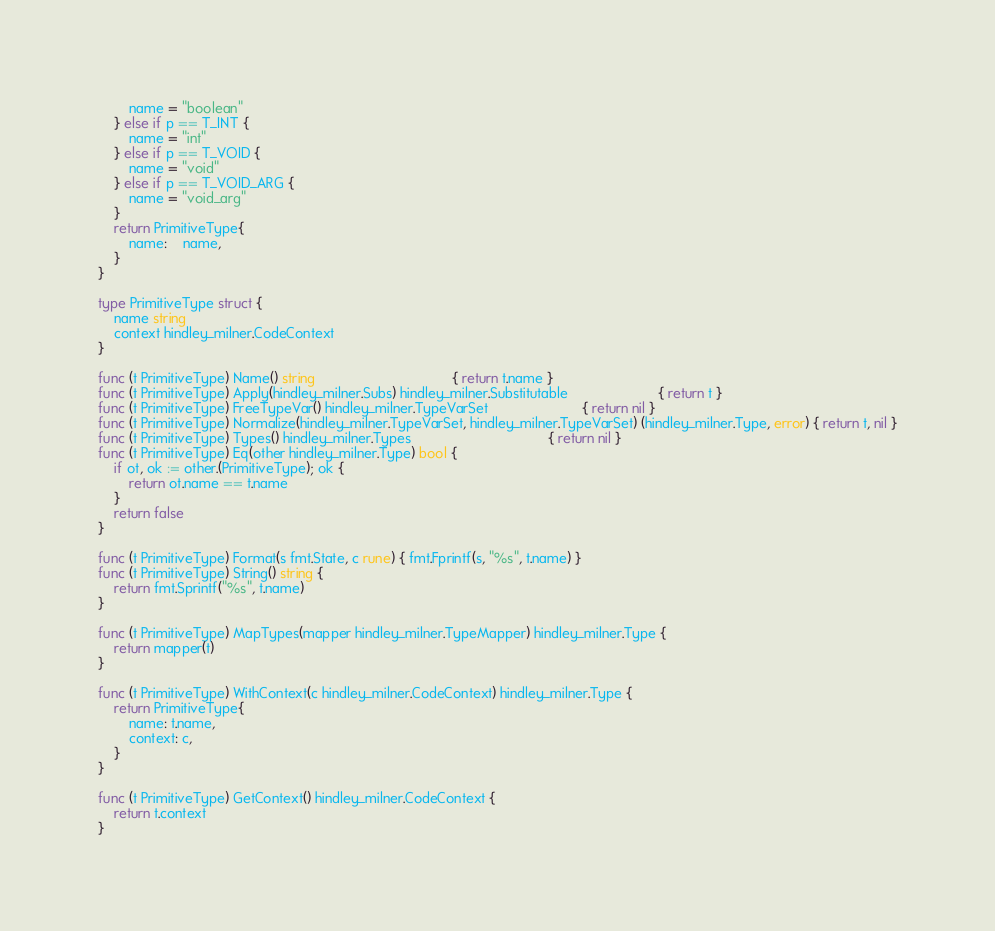<code> <loc_0><loc_0><loc_500><loc_500><_Go_>		name = "boolean"
	} else if p == T_INT {
		name = "int"
	} else if p == T_VOID {
		name = "void"
	} else if p == T_VOID_ARG {
		name = "void_arg"
	}
	return PrimitiveType{
		name:    name,
	}
}

type PrimitiveType struct {
	name string
	context hindley_milner.CodeContext
}

func (t PrimitiveType) Name() string                                   { return t.name }
func (t PrimitiveType) Apply(hindley_milner.Subs) hindley_milner.Substitutable                       { return t }
func (t PrimitiveType) FreeTypeVar() hindley_milner.TypeVarSet                        { return nil }
func (t PrimitiveType) Normalize(hindley_milner.TypeVarSet, hindley_milner.TypeVarSet) (hindley_milner.Type, error) { return t, nil }
func (t PrimitiveType) Types() hindley_milner.Types                                   { return nil }
func (t PrimitiveType) Eq(other hindley_milner.Type) bool {
	if ot, ok := other.(PrimitiveType); ok {
		return ot.name == t.name
	}
	return false
}

func (t PrimitiveType) Format(s fmt.State, c rune) { fmt.Fprintf(s, "%s", t.name) }
func (t PrimitiveType) String() string {
	return fmt.Sprintf("%s", t.name)
}

func (t PrimitiveType) MapTypes(mapper hindley_milner.TypeMapper) hindley_milner.Type {
	return mapper(t)
}

func (t PrimitiveType) WithContext(c hindley_milner.CodeContext) hindley_milner.Type {
	return PrimitiveType{
		name: t.name,
		context: c,
	}
}

func (t PrimitiveType) GetContext() hindley_milner.CodeContext {
	return t.context
}</code> 